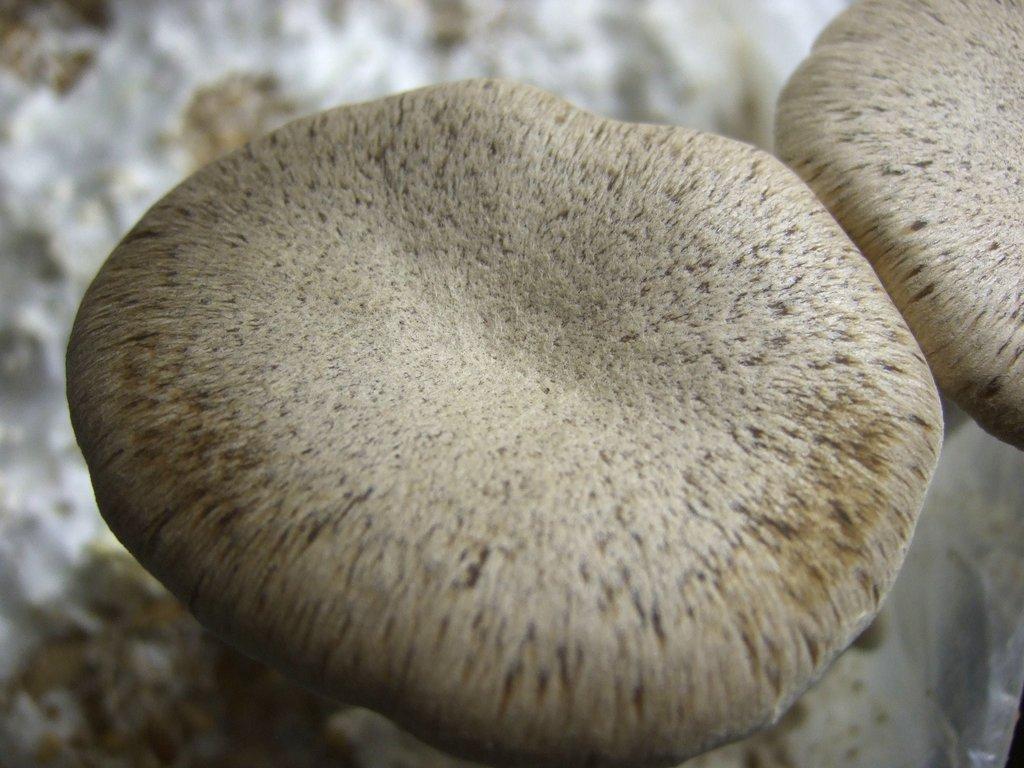What are the two grey objects in the image? There are two grey objects in the image, but their specific nature is not mentioned in the provided facts. How many dimes are visible on the grey objects in the image? There is no mention of dimes or any other specific objects in the image, so it is not possible to answer this question. 